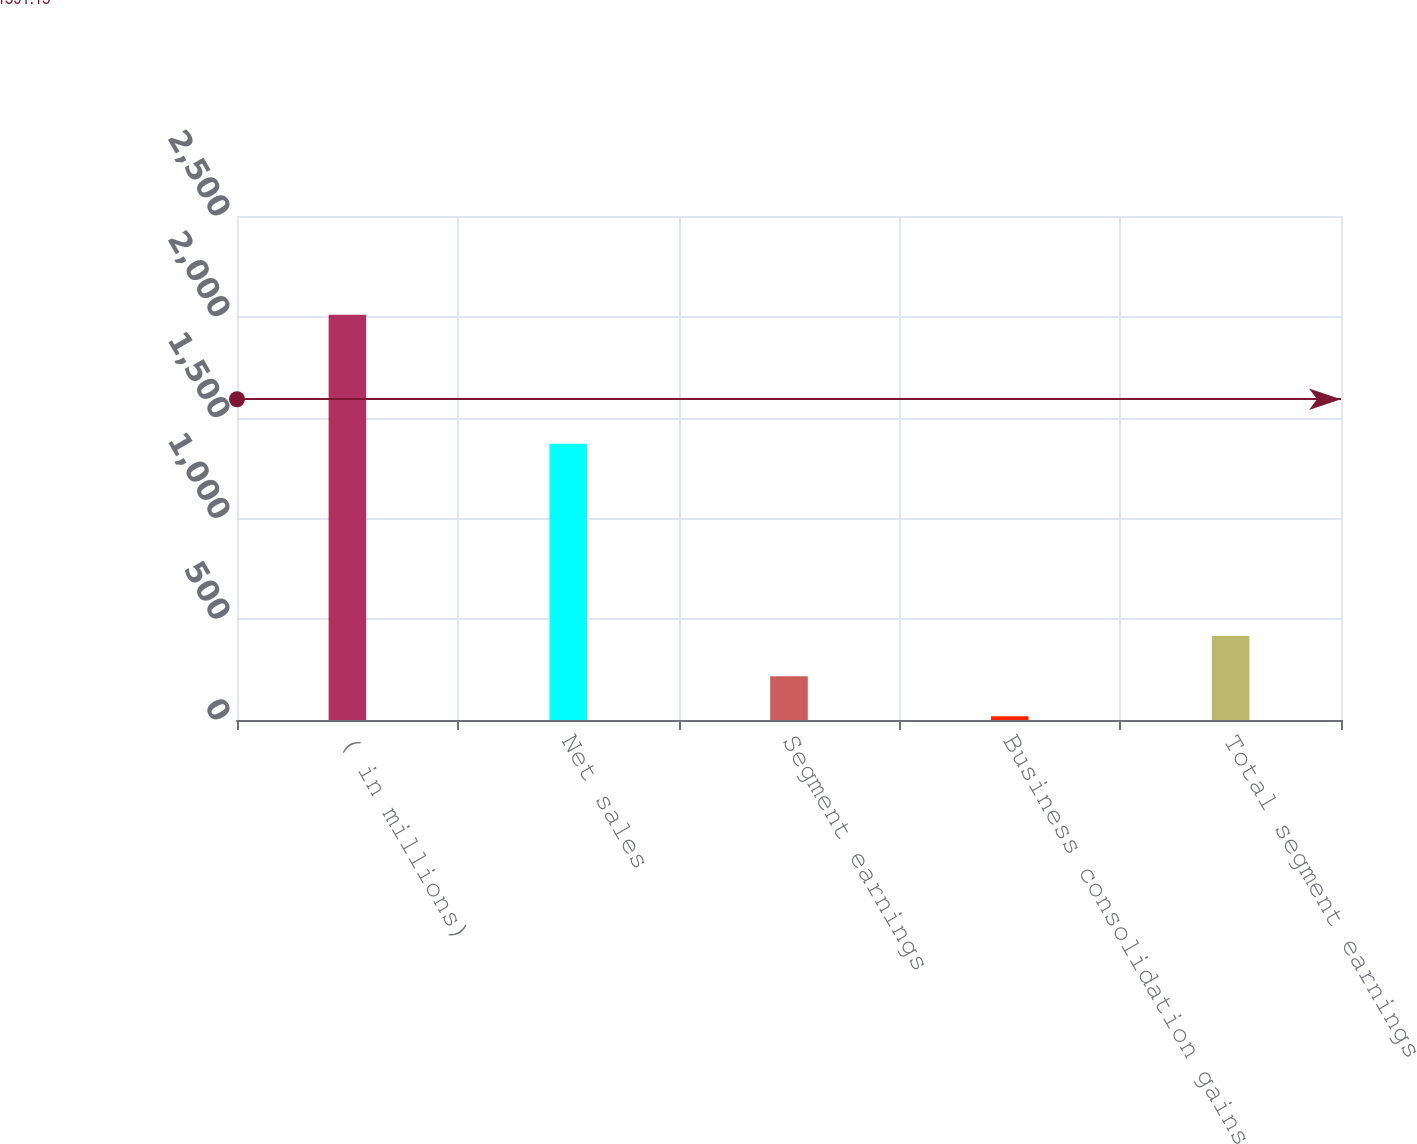<chart> <loc_0><loc_0><loc_500><loc_500><bar_chart><fcel>( in millions)<fcel>Net sales<fcel>Segment earnings<fcel>Business consolidation gains<fcel>Total segment earnings<nl><fcel>2010<fcel>1370.1<fcel>217.47<fcel>18.3<fcel>416.64<nl></chart> 